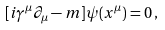Convert formula to latex. <formula><loc_0><loc_0><loc_500><loc_500>[ i \gamma ^ { \mu } \partial _ { \mu } - m ] \psi ( x ^ { \mu } ) = 0 \, ,</formula> 